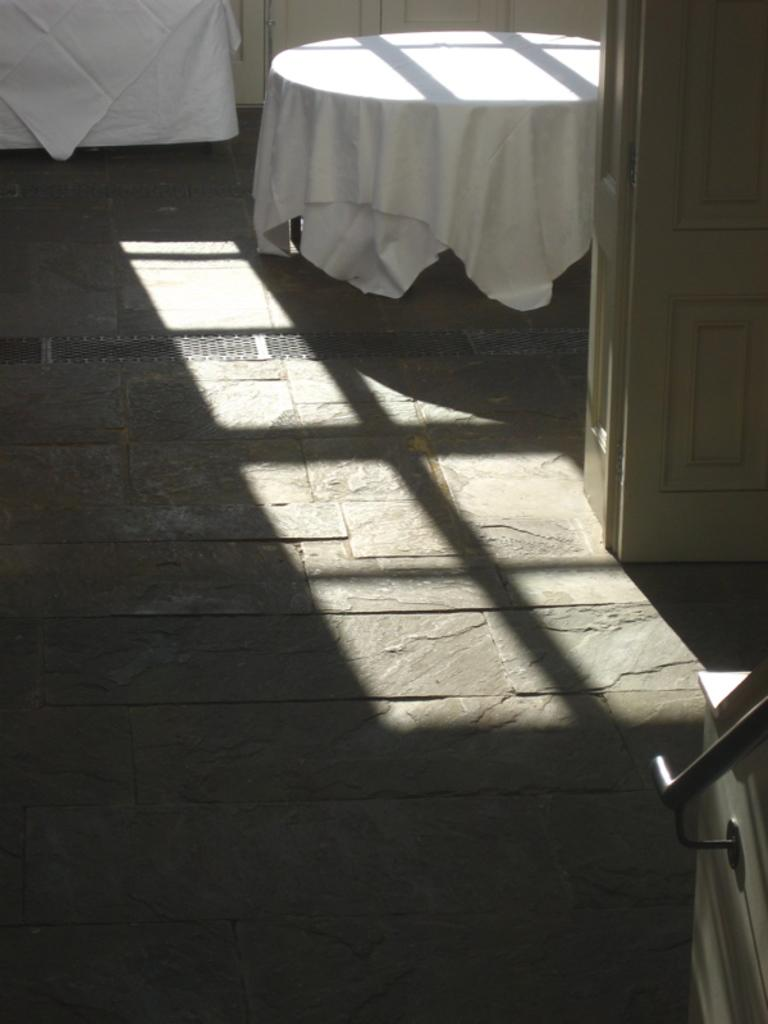What type of location is depicted in the image? The image shows an inside view of a building. What is on the table in the image? There is a table with a cloth on it. Where is the table located in the image? The table is on the floor. What can be used to enter or exit the room in the image? There is a door in the image. What object can be seen hanging in the image? There is a rod in the image. What type of stove can be seen in the image? There is no stove present in the image. What color is the heart hanging on the rod in the image? There is no heart present in the image; only a rod can be seen. 